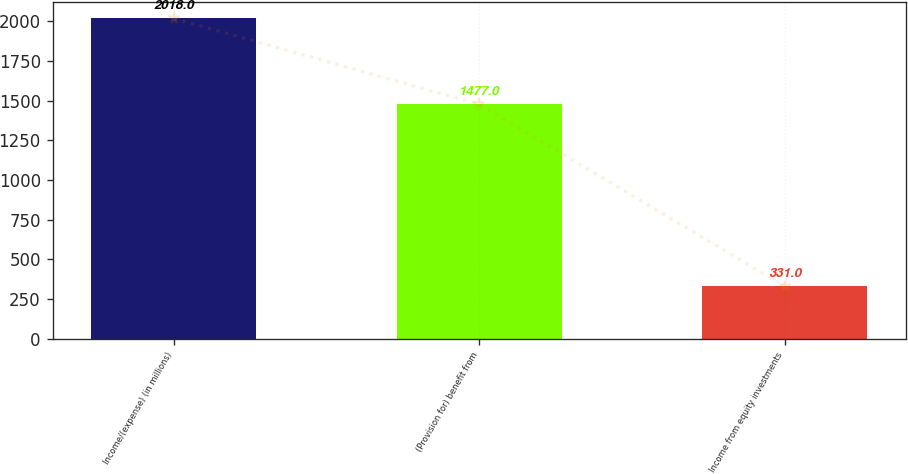Convert chart to OTSL. <chart><loc_0><loc_0><loc_500><loc_500><bar_chart><fcel>Income/(expense) (in millions)<fcel>(Provision for) benefit from<fcel>Income from equity investments<nl><fcel>2018<fcel>1477<fcel>331<nl></chart> 